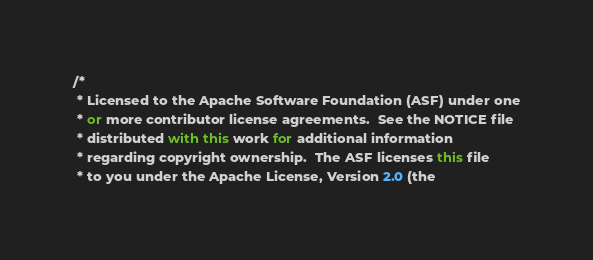Convert code to text. <code><loc_0><loc_0><loc_500><loc_500><_C#_>/*
 * Licensed to the Apache Software Foundation (ASF) under one
 * or more contributor license agreements.  See the NOTICE file
 * distributed with this work for additional information
 * regarding copyright ownership.  The ASF licenses this file
 * to you under the Apache License, Version 2.0 (the</code> 